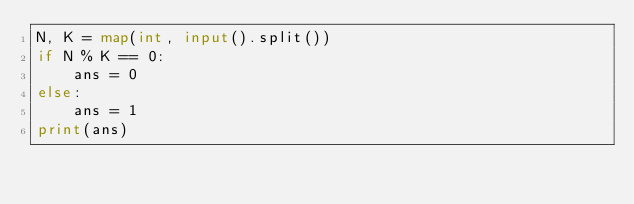<code> <loc_0><loc_0><loc_500><loc_500><_Python_>N, K = map(int, input().split())
if N % K == 0:
    ans = 0
else:
    ans = 1
print(ans)</code> 